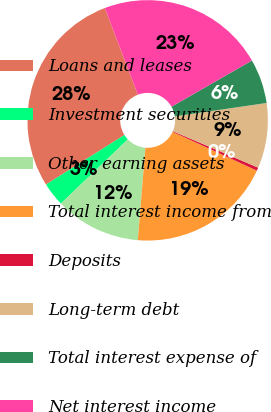<chart> <loc_0><loc_0><loc_500><loc_500><pie_chart><fcel>Loans and leases<fcel>Investment securities<fcel>Other earning assets<fcel>Total interest income from<fcel>Deposits<fcel>Long-term debt<fcel>Total interest expense of<fcel>Net interest income<nl><fcel>28.18%<fcel>3.2%<fcel>11.53%<fcel>19.44%<fcel>0.43%<fcel>8.75%<fcel>5.98%<fcel>22.51%<nl></chart> 